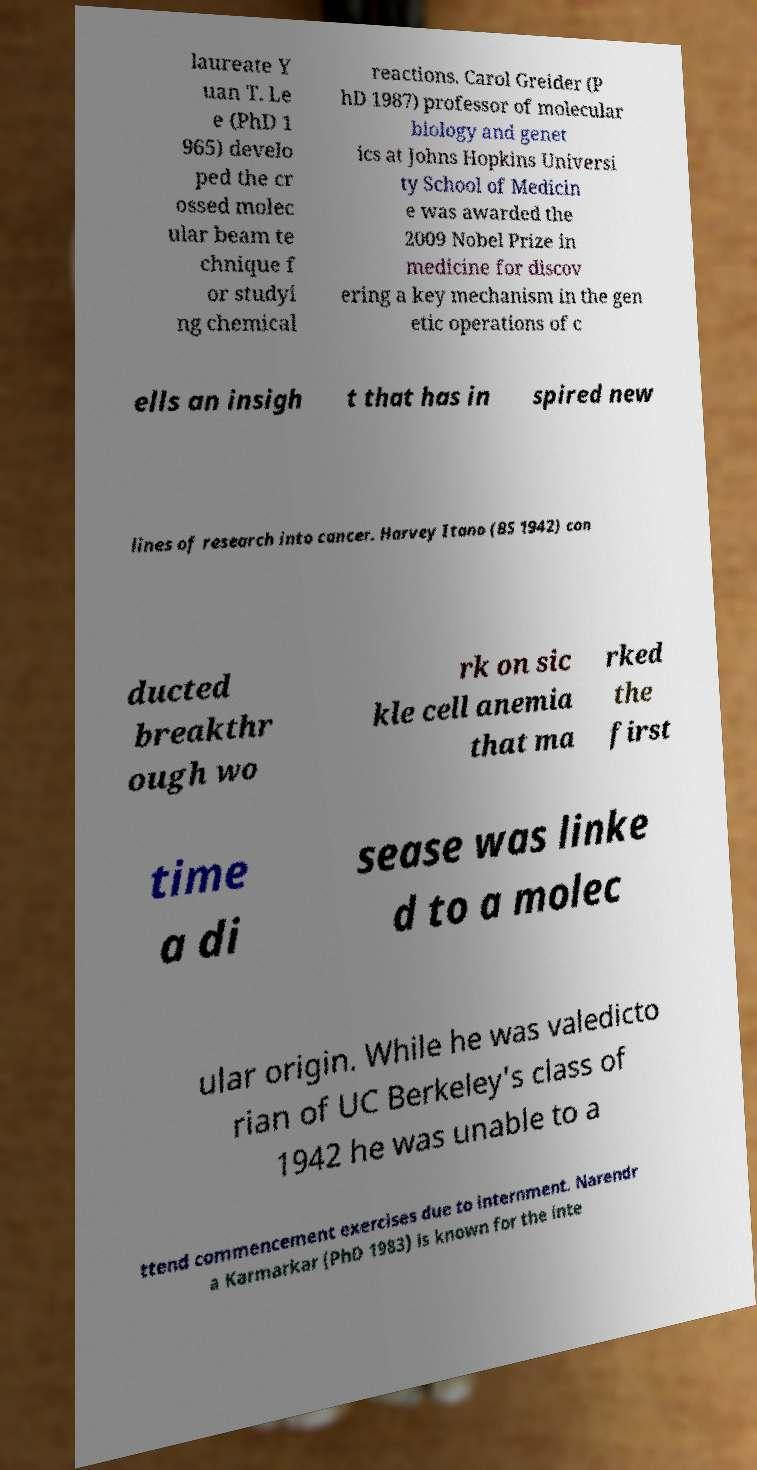Could you extract and type out the text from this image? laureate Y uan T. Le e (PhD 1 965) develo ped the cr ossed molec ular beam te chnique f or studyi ng chemical reactions. Carol Greider (P hD 1987) professor of molecular biology and genet ics at Johns Hopkins Universi ty School of Medicin e was awarded the 2009 Nobel Prize in medicine for discov ering a key mechanism in the gen etic operations of c ells an insigh t that has in spired new lines of research into cancer. Harvey Itano (BS 1942) con ducted breakthr ough wo rk on sic kle cell anemia that ma rked the first time a di sease was linke d to a molec ular origin. While he was valedicto rian of UC Berkeley's class of 1942 he was unable to a ttend commencement exercises due to internment. Narendr a Karmarkar (PhD 1983) is known for the inte 